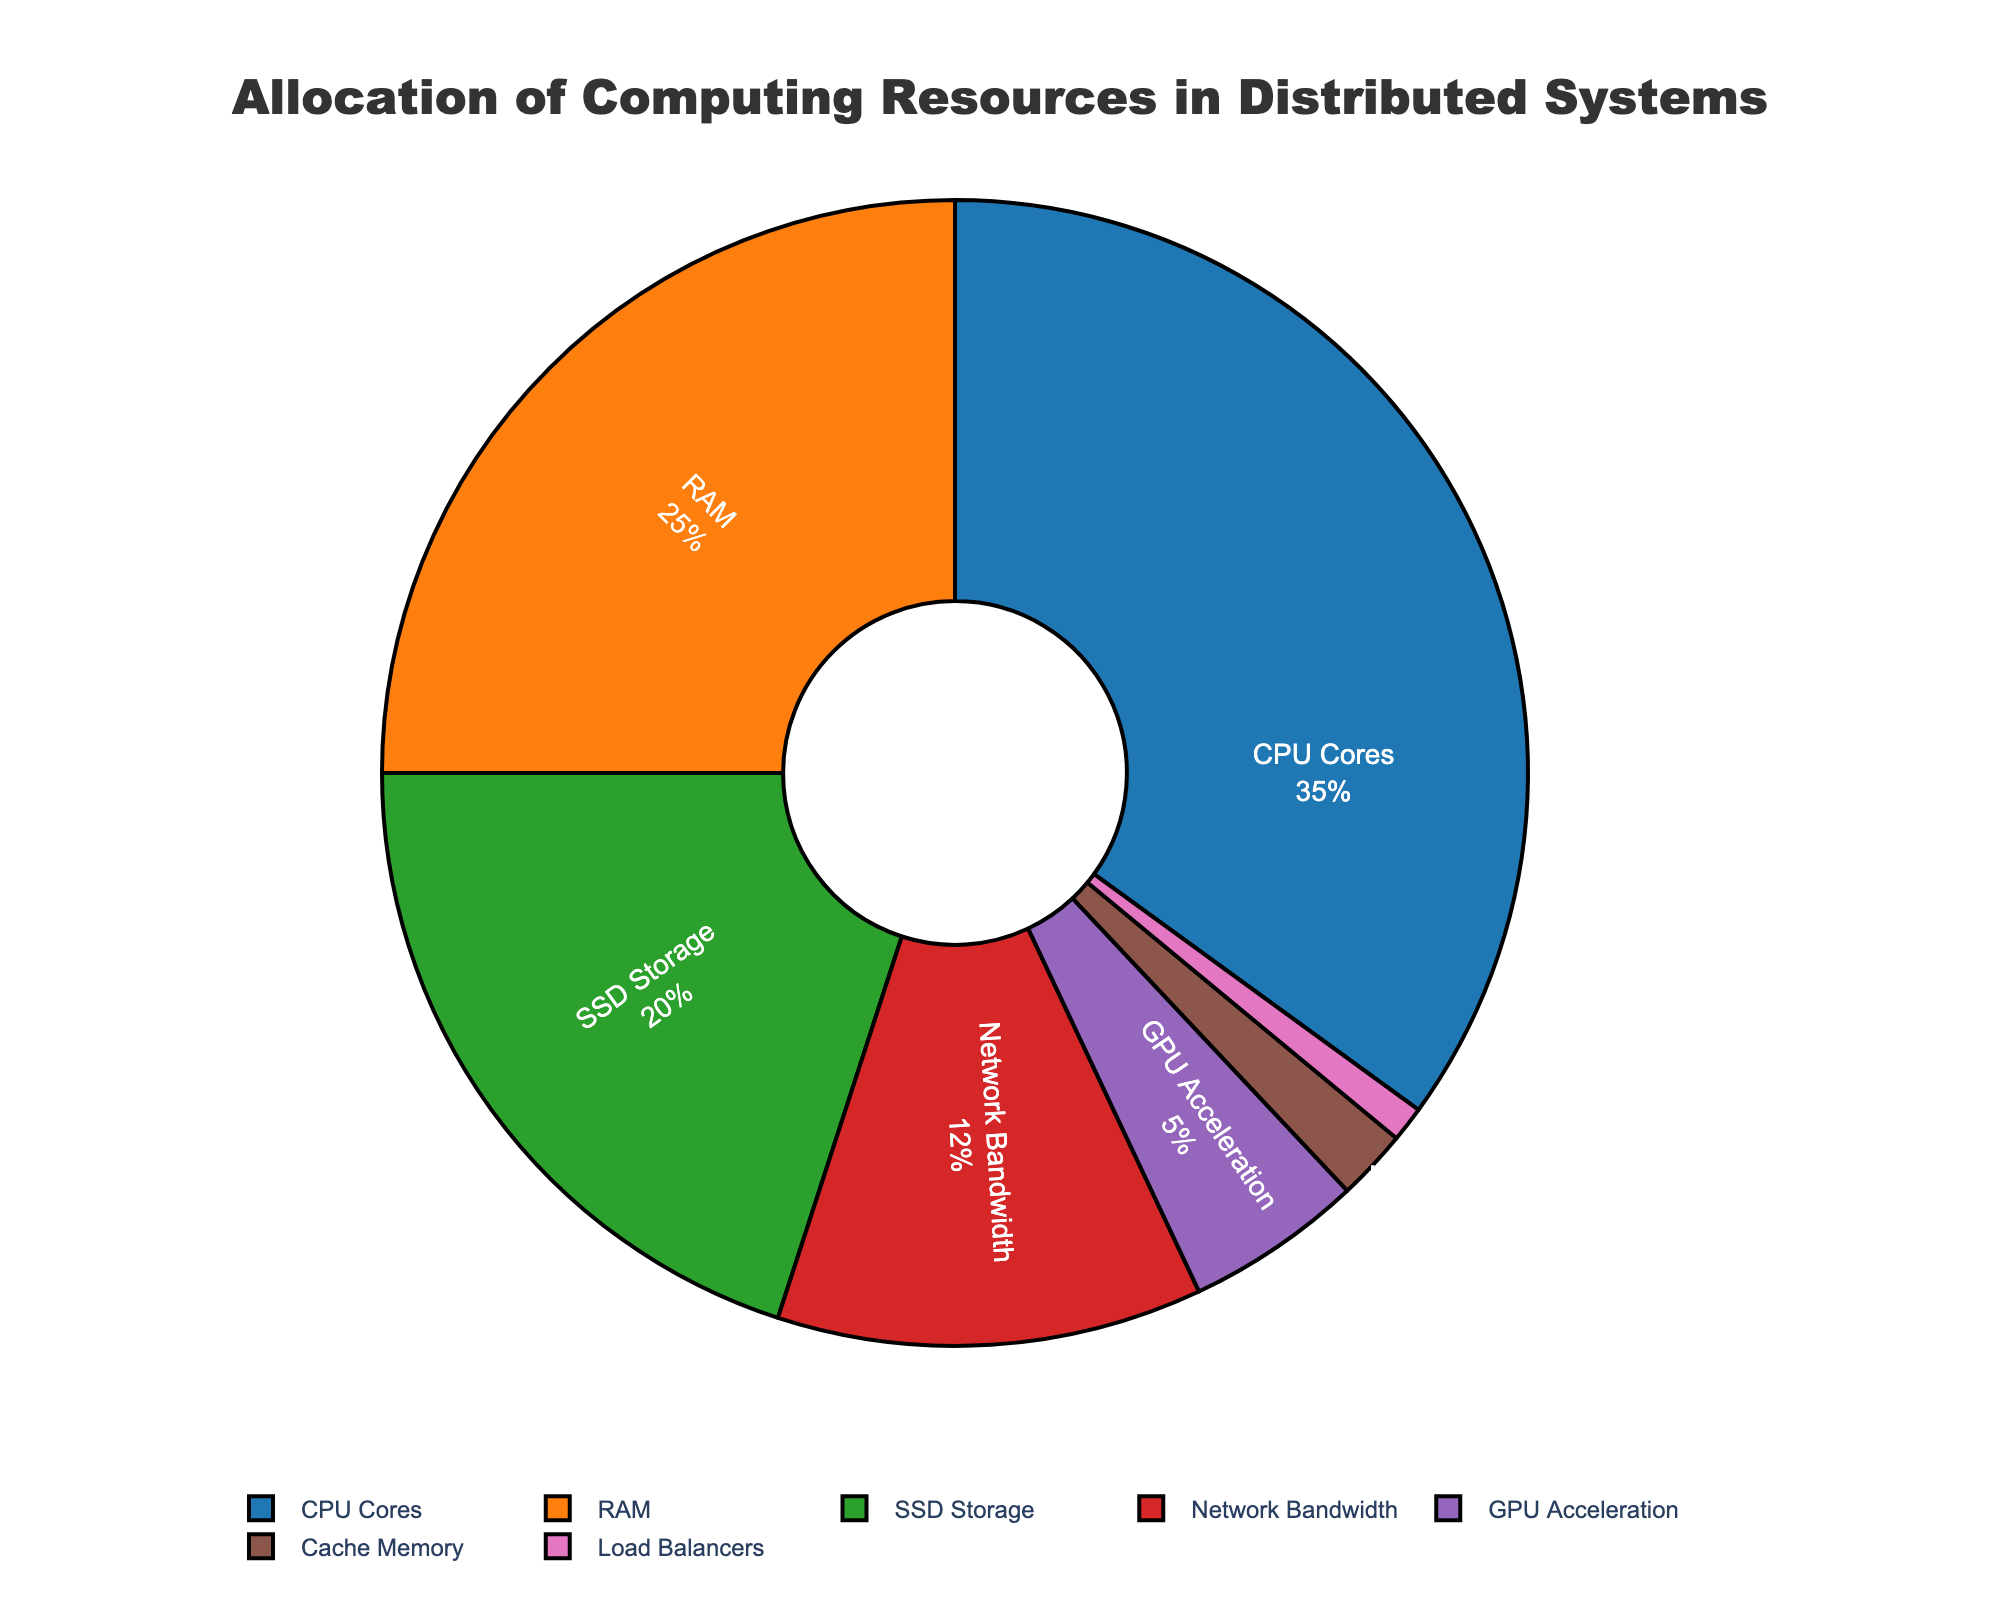what resource has the biggest allocation in the pie chart? The chart displays several resources with different allocations. By looking at the largest segment, "CPU Cores" occupies the biggest area, indicating it has the largest allocation.
Answer: CPU Cores what is the combined percentage of SSD Storage and Network Bandwidth? To get the combined percentage, we need to add the individual percentages of SSD Storage (20%) and Network Bandwidth (12%). 20 + 12 = 32
Answer: 32% which resource has the smallest portion in the pie chart? By examining the smallest segment in the pie chart, "Load Balancers" has the least allocation.
Answer: Load Balancers how does the allocation of RAM compare to GPU Acceleration? RAM has a percentage of 25%, while GPU Acceleration has 5%. Comparing these, RAM has a higher allocation by 20%.
Answer: RAM has a higher allocation what is the total percentage allocated to non-main computing resources (GPU Acceleration, Cache Memory, Load Balancers)? Summing the percentages of GPU Acceleration (5%), Cache Memory (2%), and Load Balancers (1%) gives 5 + 2 + 1 = 8%
Answer: 8% what colors represent RAM and Network Bandwidth in the pie chart? By looking at the segments, RAM is displayed in an orange color, and Network Bandwidth is displayed in red.
Answer: orange and red is the percentage allocated to GPU Acceleration greater than Cache Memory and Load Balancers combined? GPU Acceleration has 5%, while Cache Memory and Load Balancers combined have 2% + 1% = 3%. Since 5% is greater than 3%, GPU Acceleration is indeed larger.
Answer: Yes does the allocation of SSD Storage exceed half of the allocation of CPU Cores? SSD Storage is 20%, and half of CPU Cores' percentage is 35/2 = 17.5%. Yes, 20% exceeds 17.5%.
Answer: Yes how much more percentage does CPU Cores have compared to Network Bandwidth? CPU Cores have 35% while Network Bandwidth has 12%. The difference is 35 - 12 = 23%.
Answer: 23% if RAM's resource allocation increases by 5%, what would its new percentage be? Currently, RAM is at 25%. Increasing by 5% gives 25 + 5 = 30%.
Answer: 30% 